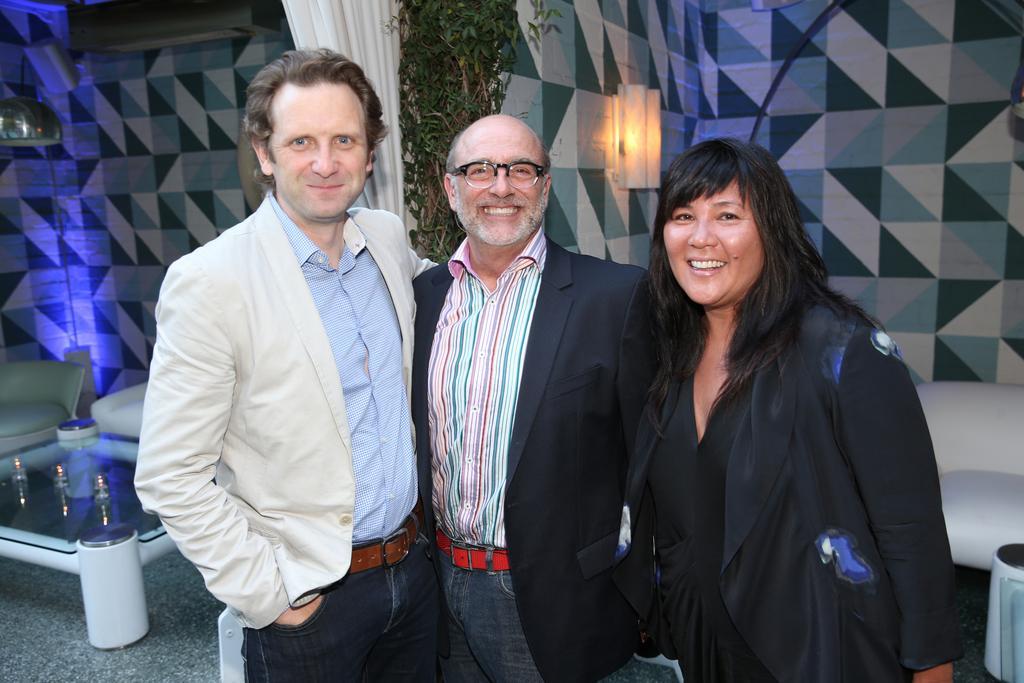Please provide a concise description of this image. In this image I can see three people with different color dresses. I can these people are smiling. To the left I can see the teapoy and the white color couches. In the background I can see the curtain and the plants. I can also see the colorful wall and the light. 